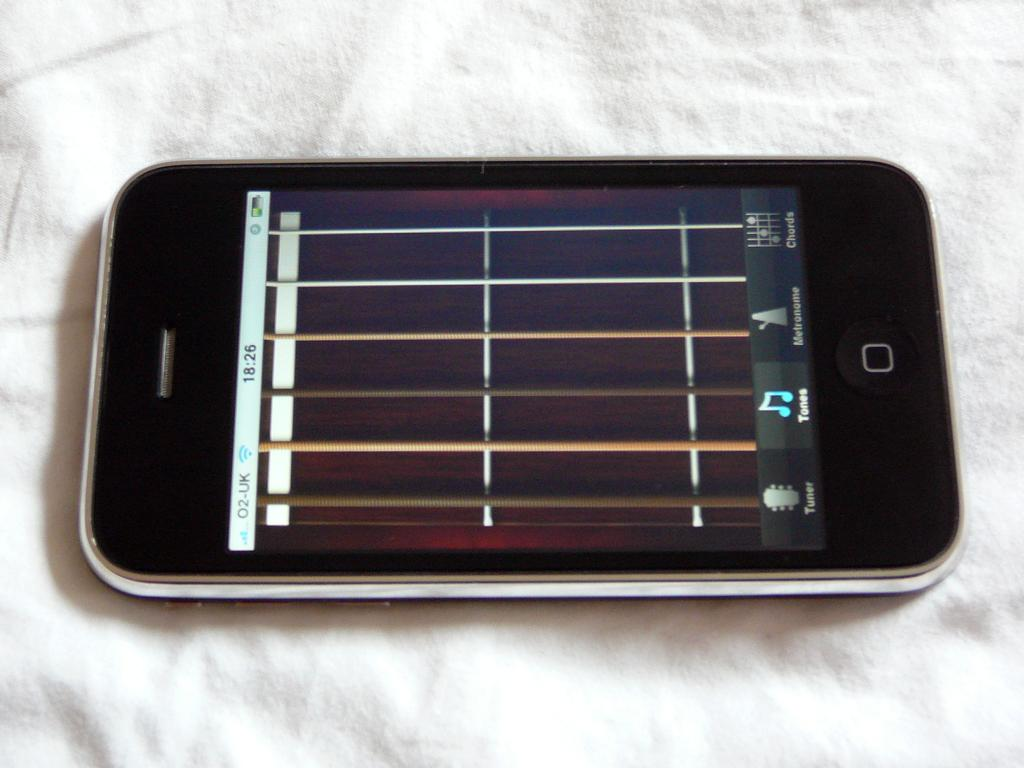Provide a one-sentence caption for the provided image. The front of a phone shows that the time is 18:26. 